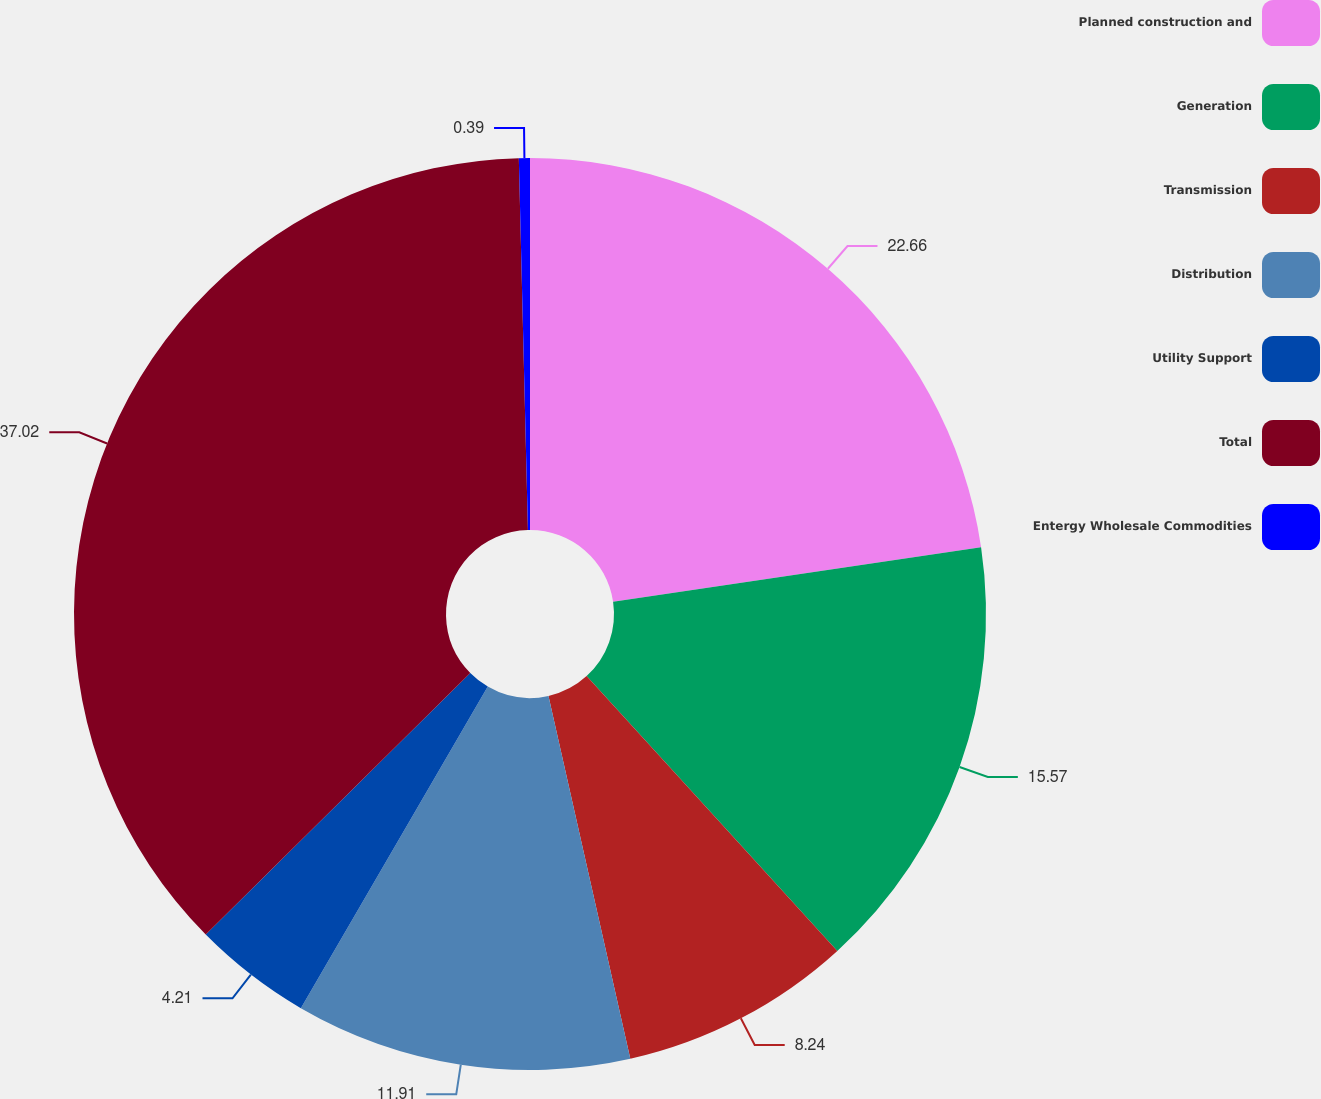Convert chart. <chart><loc_0><loc_0><loc_500><loc_500><pie_chart><fcel>Planned construction and<fcel>Generation<fcel>Transmission<fcel>Distribution<fcel>Utility Support<fcel>Total<fcel>Entergy Wholesale Commodities<nl><fcel>22.66%<fcel>15.57%<fcel>8.24%<fcel>11.91%<fcel>4.21%<fcel>37.02%<fcel>0.39%<nl></chart> 